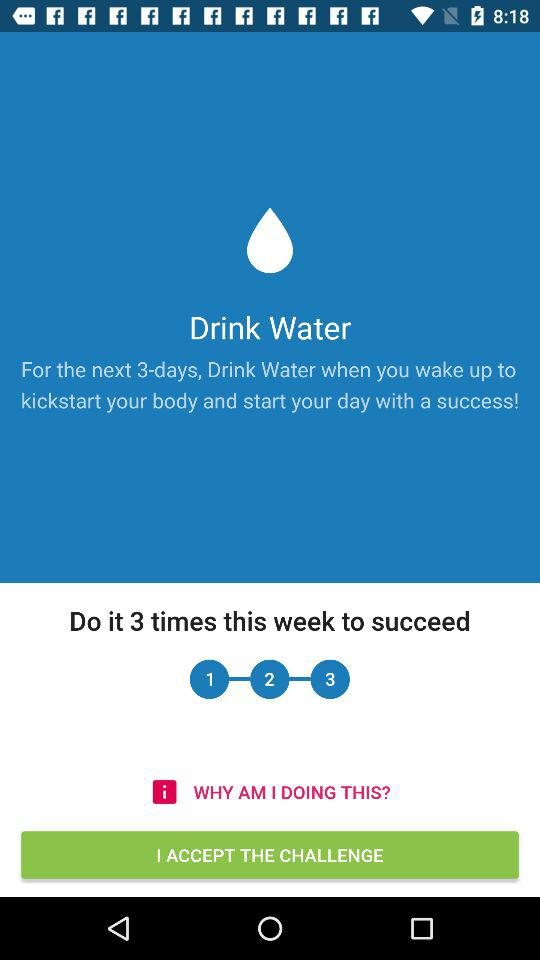How many days do I have to complete this challenge?
Answer the question using a single word or phrase. 3 